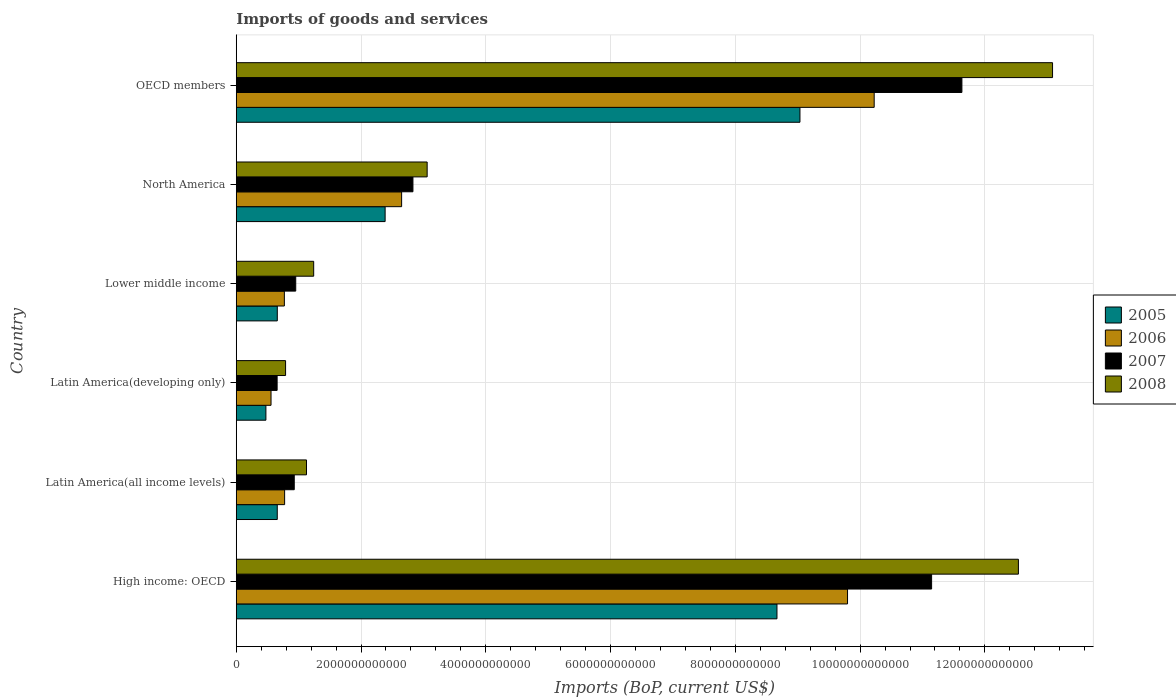How many different coloured bars are there?
Keep it short and to the point. 4. Are the number of bars per tick equal to the number of legend labels?
Offer a very short reply. Yes. Are the number of bars on each tick of the Y-axis equal?
Your answer should be compact. Yes. How many bars are there on the 1st tick from the bottom?
Make the answer very short. 4. What is the label of the 4th group of bars from the top?
Provide a short and direct response. Latin America(developing only). What is the amount spent on imports in 2005 in North America?
Give a very brief answer. 2.39e+12. Across all countries, what is the maximum amount spent on imports in 2006?
Provide a short and direct response. 1.02e+13. Across all countries, what is the minimum amount spent on imports in 2005?
Make the answer very short. 4.75e+11. In which country was the amount spent on imports in 2007 maximum?
Give a very brief answer. OECD members. In which country was the amount spent on imports in 2007 minimum?
Offer a very short reply. Latin America(developing only). What is the total amount spent on imports in 2007 in the graph?
Keep it short and to the point. 2.81e+13. What is the difference between the amount spent on imports in 2005 in Latin America(all income levels) and that in North America?
Make the answer very short. -1.73e+12. What is the difference between the amount spent on imports in 2005 in OECD members and the amount spent on imports in 2007 in Latin America(developing only)?
Keep it short and to the point. 8.38e+12. What is the average amount spent on imports in 2006 per country?
Make the answer very short. 4.13e+12. What is the difference between the amount spent on imports in 2007 and amount spent on imports in 2006 in OECD members?
Your answer should be compact. 1.41e+12. What is the ratio of the amount spent on imports in 2005 in Latin America(developing only) to that in North America?
Offer a very short reply. 0.2. Is the difference between the amount spent on imports in 2007 in Latin America(all income levels) and North America greater than the difference between the amount spent on imports in 2006 in Latin America(all income levels) and North America?
Give a very brief answer. No. What is the difference between the highest and the second highest amount spent on imports in 2005?
Provide a succinct answer. 3.68e+11. What is the difference between the highest and the lowest amount spent on imports in 2007?
Offer a terse response. 1.10e+13. Is the sum of the amount spent on imports in 2005 in Latin America(all income levels) and OECD members greater than the maximum amount spent on imports in 2007 across all countries?
Your answer should be very brief. No. Is it the case that in every country, the sum of the amount spent on imports in 2006 and amount spent on imports in 2005 is greater than the sum of amount spent on imports in 2007 and amount spent on imports in 2008?
Offer a very short reply. No. What does the 4th bar from the bottom in High income: OECD represents?
Your answer should be very brief. 2008. How many bars are there?
Your answer should be compact. 24. How many countries are there in the graph?
Offer a terse response. 6. What is the difference between two consecutive major ticks on the X-axis?
Give a very brief answer. 2.00e+12. Are the values on the major ticks of X-axis written in scientific E-notation?
Offer a very short reply. No. Where does the legend appear in the graph?
Offer a very short reply. Center right. How are the legend labels stacked?
Your response must be concise. Vertical. What is the title of the graph?
Offer a very short reply. Imports of goods and services. What is the label or title of the X-axis?
Offer a very short reply. Imports (BoP, current US$). What is the Imports (BoP, current US$) of 2005 in High income: OECD?
Ensure brevity in your answer.  8.67e+12. What is the Imports (BoP, current US$) in 2006 in High income: OECD?
Provide a short and direct response. 9.80e+12. What is the Imports (BoP, current US$) of 2007 in High income: OECD?
Offer a very short reply. 1.11e+13. What is the Imports (BoP, current US$) in 2008 in High income: OECD?
Offer a very short reply. 1.25e+13. What is the Imports (BoP, current US$) in 2005 in Latin America(all income levels)?
Offer a terse response. 6.57e+11. What is the Imports (BoP, current US$) in 2006 in Latin America(all income levels)?
Make the answer very short. 7.75e+11. What is the Imports (BoP, current US$) in 2007 in Latin America(all income levels)?
Your response must be concise. 9.30e+11. What is the Imports (BoP, current US$) in 2008 in Latin America(all income levels)?
Provide a short and direct response. 1.13e+12. What is the Imports (BoP, current US$) of 2005 in Latin America(developing only)?
Give a very brief answer. 4.75e+11. What is the Imports (BoP, current US$) of 2006 in Latin America(developing only)?
Provide a succinct answer. 5.57e+11. What is the Imports (BoP, current US$) of 2007 in Latin America(developing only)?
Your answer should be very brief. 6.55e+11. What is the Imports (BoP, current US$) of 2008 in Latin America(developing only)?
Provide a succinct answer. 7.91e+11. What is the Imports (BoP, current US$) of 2005 in Lower middle income?
Provide a short and direct response. 6.58e+11. What is the Imports (BoP, current US$) in 2006 in Lower middle income?
Your answer should be very brief. 7.71e+11. What is the Imports (BoP, current US$) in 2007 in Lower middle income?
Keep it short and to the point. 9.53e+11. What is the Imports (BoP, current US$) in 2008 in Lower middle income?
Keep it short and to the point. 1.24e+12. What is the Imports (BoP, current US$) of 2005 in North America?
Ensure brevity in your answer.  2.39e+12. What is the Imports (BoP, current US$) of 2006 in North America?
Keep it short and to the point. 2.65e+12. What is the Imports (BoP, current US$) of 2007 in North America?
Offer a very short reply. 2.83e+12. What is the Imports (BoP, current US$) of 2008 in North America?
Your response must be concise. 3.06e+12. What is the Imports (BoP, current US$) in 2005 in OECD members?
Offer a very short reply. 9.04e+12. What is the Imports (BoP, current US$) of 2006 in OECD members?
Offer a very short reply. 1.02e+13. What is the Imports (BoP, current US$) in 2007 in OECD members?
Make the answer very short. 1.16e+13. What is the Imports (BoP, current US$) of 2008 in OECD members?
Provide a succinct answer. 1.31e+13. Across all countries, what is the maximum Imports (BoP, current US$) in 2005?
Keep it short and to the point. 9.04e+12. Across all countries, what is the maximum Imports (BoP, current US$) in 2006?
Ensure brevity in your answer.  1.02e+13. Across all countries, what is the maximum Imports (BoP, current US$) in 2007?
Provide a succinct answer. 1.16e+13. Across all countries, what is the maximum Imports (BoP, current US$) of 2008?
Make the answer very short. 1.31e+13. Across all countries, what is the minimum Imports (BoP, current US$) in 2005?
Make the answer very short. 4.75e+11. Across all countries, what is the minimum Imports (BoP, current US$) in 2006?
Offer a very short reply. 5.57e+11. Across all countries, what is the minimum Imports (BoP, current US$) in 2007?
Your answer should be very brief. 6.55e+11. Across all countries, what is the minimum Imports (BoP, current US$) of 2008?
Offer a terse response. 7.91e+11. What is the total Imports (BoP, current US$) in 2005 in the graph?
Make the answer very short. 2.19e+13. What is the total Imports (BoP, current US$) of 2006 in the graph?
Give a very brief answer. 2.48e+13. What is the total Imports (BoP, current US$) of 2007 in the graph?
Make the answer very short. 2.81e+13. What is the total Imports (BoP, current US$) of 2008 in the graph?
Ensure brevity in your answer.  3.18e+13. What is the difference between the Imports (BoP, current US$) in 2005 in High income: OECD and that in Latin America(all income levels)?
Offer a very short reply. 8.01e+12. What is the difference between the Imports (BoP, current US$) of 2006 in High income: OECD and that in Latin America(all income levels)?
Your answer should be compact. 9.02e+12. What is the difference between the Imports (BoP, current US$) of 2007 in High income: OECD and that in Latin America(all income levels)?
Your answer should be compact. 1.02e+13. What is the difference between the Imports (BoP, current US$) in 2008 in High income: OECD and that in Latin America(all income levels)?
Offer a very short reply. 1.14e+13. What is the difference between the Imports (BoP, current US$) of 2005 in High income: OECD and that in Latin America(developing only)?
Make the answer very short. 8.19e+12. What is the difference between the Imports (BoP, current US$) of 2006 in High income: OECD and that in Latin America(developing only)?
Offer a terse response. 9.24e+12. What is the difference between the Imports (BoP, current US$) of 2007 in High income: OECD and that in Latin America(developing only)?
Provide a short and direct response. 1.05e+13. What is the difference between the Imports (BoP, current US$) in 2008 in High income: OECD and that in Latin America(developing only)?
Your response must be concise. 1.17e+13. What is the difference between the Imports (BoP, current US$) of 2005 in High income: OECD and that in Lower middle income?
Give a very brief answer. 8.01e+12. What is the difference between the Imports (BoP, current US$) in 2006 in High income: OECD and that in Lower middle income?
Make the answer very short. 9.03e+12. What is the difference between the Imports (BoP, current US$) in 2007 in High income: OECD and that in Lower middle income?
Offer a terse response. 1.02e+13. What is the difference between the Imports (BoP, current US$) of 2008 in High income: OECD and that in Lower middle income?
Provide a short and direct response. 1.13e+13. What is the difference between the Imports (BoP, current US$) of 2005 in High income: OECD and that in North America?
Make the answer very short. 6.28e+12. What is the difference between the Imports (BoP, current US$) of 2006 in High income: OECD and that in North America?
Your response must be concise. 7.15e+12. What is the difference between the Imports (BoP, current US$) in 2007 in High income: OECD and that in North America?
Your answer should be very brief. 8.31e+12. What is the difference between the Imports (BoP, current US$) in 2008 in High income: OECD and that in North America?
Your response must be concise. 9.48e+12. What is the difference between the Imports (BoP, current US$) in 2005 in High income: OECD and that in OECD members?
Offer a very short reply. -3.68e+11. What is the difference between the Imports (BoP, current US$) of 2006 in High income: OECD and that in OECD members?
Your answer should be very brief. -4.27e+11. What is the difference between the Imports (BoP, current US$) of 2007 in High income: OECD and that in OECD members?
Your answer should be compact. -4.86e+11. What is the difference between the Imports (BoP, current US$) in 2008 in High income: OECD and that in OECD members?
Provide a short and direct response. -5.47e+11. What is the difference between the Imports (BoP, current US$) in 2005 in Latin America(all income levels) and that in Latin America(developing only)?
Your response must be concise. 1.82e+11. What is the difference between the Imports (BoP, current US$) in 2006 in Latin America(all income levels) and that in Latin America(developing only)?
Keep it short and to the point. 2.18e+11. What is the difference between the Imports (BoP, current US$) in 2007 in Latin America(all income levels) and that in Latin America(developing only)?
Keep it short and to the point. 2.75e+11. What is the difference between the Imports (BoP, current US$) in 2008 in Latin America(all income levels) and that in Latin America(developing only)?
Your answer should be compact. 3.35e+11. What is the difference between the Imports (BoP, current US$) of 2005 in Latin America(all income levels) and that in Lower middle income?
Give a very brief answer. -6.55e+08. What is the difference between the Imports (BoP, current US$) of 2006 in Latin America(all income levels) and that in Lower middle income?
Keep it short and to the point. 4.18e+09. What is the difference between the Imports (BoP, current US$) in 2007 in Latin America(all income levels) and that in Lower middle income?
Offer a very short reply. -2.36e+1. What is the difference between the Imports (BoP, current US$) in 2008 in Latin America(all income levels) and that in Lower middle income?
Keep it short and to the point. -1.15e+11. What is the difference between the Imports (BoP, current US$) of 2005 in Latin America(all income levels) and that in North America?
Offer a terse response. -1.73e+12. What is the difference between the Imports (BoP, current US$) in 2006 in Latin America(all income levels) and that in North America?
Make the answer very short. -1.88e+12. What is the difference between the Imports (BoP, current US$) in 2007 in Latin America(all income levels) and that in North America?
Ensure brevity in your answer.  -1.90e+12. What is the difference between the Imports (BoP, current US$) of 2008 in Latin America(all income levels) and that in North America?
Your answer should be compact. -1.93e+12. What is the difference between the Imports (BoP, current US$) of 2005 in Latin America(all income levels) and that in OECD members?
Offer a terse response. -8.38e+12. What is the difference between the Imports (BoP, current US$) in 2006 in Latin America(all income levels) and that in OECD members?
Make the answer very short. -9.45e+12. What is the difference between the Imports (BoP, current US$) in 2007 in Latin America(all income levels) and that in OECD members?
Offer a terse response. -1.07e+13. What is the difference between the Imports (BoP, current US$) of 2008 in Latin America(all income levels) and that in OECD members?
Your answer should be compact. -1.20e+13. What is the difference between the Imports (BoP, current US$) in 2005 in Latin America(developing only) and that in Lower middle income?
Provide a succinct answer. -1.83e+11. What is the difference between the Imports (BoP, current US$) in 2006 in Latin America(developing only) and that in Lower middle income?
Provide a succinct answer. -2.14e+11. What is the difference between the Imports (BoP, current US$) of 2007 in Latin America(developing only) and that in Lower middle income?
Keep it short and to the point. -2.98e+11. What is the difference between the Imports (BoP, current US$) of 2008 in Latin America(developing only) and that in Lower middle income?
Make the answer very short. -4.51e+11. What is the difference between the Imports (BoP, current US$) of 2005 in Latin America(developing only) and that in North America?
Ensure brevity in your answer.  -1.91e+12. What is the difference between the Imports (BoP, current US$) in 2006 in Latin America(developing only) and that in North America?
Keep it short and to the point. -2.09e+12. What is the difference between the Imports (BoP, current US$) of 2007 in Latin America(developing only) and that in North America?
Provide a succinct answer. -2.18e+12. What is the difference between the Imports (BoP, current US$) in 2008 in Latin America(developing only) and that in North America?
Provide a succinct answer. -2.27e+12. What is the difference between the Imports (BoP, current US$) of 2005 in Latin America(developing only) and that in OECD members?
Your answer should be compact. -8.56e+12. What is the difference between the Imports (BoP, current US$) of 2006 in Latin America(developing only) and that in OECD members?
Offer a terse response. -9.67e+12. What is the difference between the Imports (BoP, current US$) in 2007 in Latin America(developing only) and that in OECD members?
Ensure brevity in your answer.  -1.10e+13. What is the difference between the Imports (BoP, current US$) in 2008 in Latin America(developing only) and that in OECD members?
Offer a terse response. -1.23e+13. What is the difference between the Imports (BoP, current US$) in 2005 in Lower middle income and that in North America?
Your answer should be very brief. -1.73e+12. What is the difference between the Imports (BoP, current US$) in 2006 in Lower middle income and that in North America?
Ensure brevity in your answer.  -1.88e+12. What is the difference between the Imports (BoP, current US$) of 2007 in Lower middle income and that in North America?
Offer a very short reply. -1.88e+12. What is the difference between the Imports (BoP, current US$) in 2008 in Lower middle income and that in North America?
Ensure brevity in your answer.  -1.82e+12. What is the difference between the Imports (BoP, current US$) in 2005 in Lower middle income and that in OECD members?
Your response must be concise. -8.38e+12. What is the difference between the Imports (BoP, current US$) in 2006 in Lower middle income and that in OECD members?
Offer a very short reply. -9.45e+12. What is the difference between the Imports (BoP, current US$) in 2007 in Lower middle income and that in OECD members?
Keep it short and to the point. -1.07e+13. What is the difference between the Imports (BoP, current US$) in 2008 in Lower middle income and that in OECD members?
Keep it short and to the point. -1.18e+13. What is the difference between the Imports (BoP, current US$) of 2005 in North America and that in OECD members?
Make the answer very short. -6.65e+12. What is the difference between the Imports (BoP, current US$) of 2006 in North America and that in OECD members?
Offer a very short reply. -7.57e+12. What is the difference between the Imports (BoP, current US$) of 2007 in North America and that in OECD members?
Your response must be concise. -8.80e+12. What is the difference between the Imports (BoP, current US$) of 2008 in North America and that in OECD members?
Make the answer very short. -1.00e+13. What is the difference between the Imports (BoP, current US$) of 2005 in High income: OECD and the Imports (BoP, current US$) of 2006 in Latin America(all income levels)?
Give a very brief answer. 7.89e+12. What is the difference between the Imports (BoP, current US$) in 2005 in High income: OECD and the Imports (BoP, current US$) in 2007 in Latin America(all income levels)?
Your answer should be compact. 7.74e+12. What is the difference between the Imports (BoP, current US$) in 2005 in High income: OECD and the Imports (BoP, current US$) in 2008 in Latin America(all income levels)?
Provide a short and direct response. 7.54e+12. What is the difference between the Imports (BoP, current US$) of 2006 in High income: OECD and the Imports (BoP, current US$) of 2007 in Latin America(all income levels)?
Give a very brief answer. 8.87e+12. What is the difference between the Imports (BoP, current US$) of 2006 in High income: OECD and the Imports (BoP, current US$) of 2008 in Latin America(all income levels)?
Offer a terse response. 8.67e+12. What is the difference between the Imports (BoP, current US$) of 2007 in High income: OECD and the Imports (BoP, current US$) of 2008 in Latin America(all income levels)?
Give a very brief answer. 1.00e+13. What is the difference between the Imports (BoP, current US$) in 2005 in High income: OECD and the Imports (BoP, current US$) in 2006 in Latin America(developing only)?
Offer a very short reply. 8.11e+12. What is the difference between the Imports (BoP, current US$) of 2005 in High income: OECD and the Imports (BoP, current US$) of 2007 in Latin America(developing only)?
Make the answer very short. 8.01e+12. What is the difference between the Imports (BoP, current US$) of 2005 in High income: OECD and the Imports (BoP, current US$) of 2008 in Latin America(developing only)?
Your answer should be very brief. 7.88e+12. What is the difference between the Imports (BoP, current US$) in 2006 in High income: OECD and the Imports (BoP, current US$) in 2007 in Latin America(developing only)?
Your answer should be compact. 9.14e+12. What is the difference between the Imports (BoP, current US$) in 2006 in High income: OECD and the Imports (BoP, current US$) in 2008 in Latin America(developing only)?
Provide a succinct answer. 9.01e+12. What is the difference between the Imports (BoP, current US$) in 2007 in High income: OECD and the Imports (BoP, current US$) in 2008 in Latin America(developing only)?
Ensure brevity in your answer.  1.04e+13. What is the difference between the Imports (BoP, current US$) in 2005 in High income: OECD and the Imports (BoP, current US$) in 2006 in Lower middle income?
Your answer should be compact. 7.90e+12. What is the difference between the Imports (BoP, current US$) in 2005 in High income: OECD and the Imports (BoP, current US$) in 2007 in Lower middle income?
Make the answer very short. 7.71e+12. What is the difference between the Imports (BoP, current US$) of 2005 in High income: OECD and the Imports (BoP, current US$) of 2008 in Lower middle income?
Your answer should be compact. 7.43e+12. What is the difference between the Imports (BoP, current US$) in 2006 in High income: OECD and the Imports (BoP, current US$) in 2007 in Lower middle income?
Provide a short and direct response. 8.85e+12. What is the difference between the Imports (BoP, current US$) in 2006 in High income: OECD and the Imports (BoP, current US$) in 2008 in Lower middle income?
Ensure brevity in your answer.  8.56e+12. What is the difference between the Imports (BoP, current US$) in 2007 in High income: OECD and the Imports (BoP, current US$) in 2008 in Lower middle income?
Your answer should be compact. 9.91e+12. What is the difference between the Imports (BoP, current US$) in 2005 in High income: OECD and the Imports (BoP, current US$) in 2006 in North America?
Make the answer very short. 6.02e+12. What is the difference between the Imports (BoP, current US$) of 2005 in High income: OECD and the Imports (BoP, current US$) of 2007 in North America?
Your answer should be compact. 5.84e+12. What is the difference between the Imports (BoP, current US$) of 2005 in High income: OECD and the Imports (BoP, current US$) of 2008 in North America?
Keep it short and to the point. 5.61e+12. What is the difference between the Imports (BoP, current US$) in 2006 in High income: OECD and the Imports (BoP, current US$) in 2007 in North America?
Provide a short and direct response. 6.97e+12. What is the difference between the Imports (BoP, current US$) in 2006 in High income: OECD and the Imports (BoP, current US$) in 2008 in North America?
Provide a short and direct response. 6.74e+12. What is the difference between the Imports (BoP, current US$) of 2007 in High income: OECD and the Imports (BoP, current US$) of 2008 in North America?
Offer a terse response. 8.09e+12. What is the difference between the Imports (BoP, current US$) of 2005 in High income: OECD and the Imports (BoP, current US$) of 2006 in OECD members?
Offer a very short reply. -1.56e+12. What is the difference between the Imports (BoP, current US$) of 2005 in High income: OECD and the Imports (BoP, current US$) of 2007 in OECD members?
Provide a short and direct response. -2.96e+12. What is the difference between the Imports (BoP, current US$) in 2005 in High income: OECD and the Imports (BoP, current US$) in 2008 in OECD members?
Your answer should be compact. -4.42e+12. What is the difference between the Imports (BoP, current US$) of 2006 in High income: OECD and the Imports (BoP, current US$) of 2007 in OECD members?
Provide a succinct answer. -1.83e+12. What is the difference between the Imports (BoP, current US$) of 2006 in High income: OECD and the Imports (BoP, current US$) of 2008 in OECD members?
Offer a terse response. -3.29e+12. What is the difference between the Imports (BoP, current US$) in 2007 in High income: OECD and the Imports (BoP, current US$) in 2008 in OECD members?
Offer a very short reply. -1.94e+12. What is the difference between the Imports (BoP, current US$) of 2005 in Latin America(all income levels) and the Imports (BoP, current US$) of 2006 in Latin America(developing only)?
Your response must be concise. 9.99e+1. What is the difference between the Imports (BoP, current US$) of 2005 in Latin America(all income levels) and the Imports (BoP, current US$) of 2007 in Latin America(developing only)?
Ensure brevity in your answer.  2.04e+09. What is the difference between the Imports (BoP, current US$) of 2005 in Latin America(all income levels) and the Imports (BoP, current US$) of 2008 in Latin America(developing only)?
Provide a succinct answer. -1.33e+11. What is the difference between the Imports (BoP, current US$) in 2006 in Latin America(all income levels) and the Imports (BoP, current US$) in 2007 in Latin America(developing only)?
Give a very brief answer. 1.20e+11. What is the difference between the Imports (BoP, current US$) of 2006 in Latin America(all income levels) and the Imports (BoP, current US$) of 2008 in Latin America(developing only)?
Make the answer very short. -1.55e+1. What is the difference between the Imports (BoP, current US$) in 2007 in Latin America(all income levels) and the Imports (BoP, current US$) in 2008 in Latin America(developing only)?
Offer a terse response. 1.39e+11. What is the difference between the Imports (BoP, current US$) in 2005 in Latin America(all income levels) and the Imports (BoP, current US$) in 2006 in Lower middle income?
Ensure brevity in your answer.  -1.14e+11. What is the difference between the Imports (BoP, current US$) in 2005 in Latin America(all income levels) and the Imports (BoP, current US$) in 2007 in Lower middle income?
Your response must be concise. -2.96e+11. What is the difference between the Imports (BoP, current US$) in 2005 in Latin America(all income levels) and the Imports (BoP, current US$) in 2008 in Lower middle income?
Give a very brief answer. -5.84e+11. What is the difference between the Imports (BoP, current US$) in 2006 in Latin America(all income levels) and the Imports (BoP, current US$) in 2007 in Lower middle income?
Your answer should be compact. -1.78e+11. What is the difference between the Imports (BoP, current US$) of 2006 in Latin America(all income levels) and the Imports (BoP, current US$) of 2008 in Lower middle income?
Your answer should be compact. -4.66e+11. What is the difference between the Imports (BoP, current US$) in 2007 in Latin America(all income levels) and the Imports (BoP, current US$) in 2008 in Lower middle income?
Your answer should be very brief. -3.12e+11. What is the difference between the Imports (BoP, current US$) in 2005 in Latin America(all income levels) and the Imports (BoP, current US$) in 2006 in North America?
Provide a succinct answer. -1.99e+12. What is the difference between the Imports (BoP, current US$) of 2005 in Latin America(all income levels) and the Imports (BoP, current US$) of 2007 in North America?
Provide a succinct answer. -2.17e+12. What is the difference between the Imports (BoP, current US$) in 2005 in Latin America(all income levels) and the Imports (BoP, current US$) in 2008 in North America?
Your response must be concise. -2.40e+12. What is the difference between the Imports (BoP, current US$) in 2006 in Latin America(all income levels) and the Imports (BoP, current US$) in 2007 in North America?
Offer a terse response. -2.06e+12. What is the difference between the Imports (BoP, current US$) in 2006 in Latin America(all income levels) and the Imports (BoP, current US$) in 2008 in North America?
Make the answer very short. -2.28e+12. What is the difference between the Imports (BoP, current US$) of 2007 in Latin America(all income levels) and the Imports (BoP, current US$) of 2008 in North America?
Make the answer very short. -2.13e+12. What is the difference between the Imports (BoP, current US$) of 2005 in Latin America(all income levels) and the Imports (BoP, current US$) of 2006 in OECD members?
Give a very brief answer. -9.57e+12. What is the difference between the Imports (BoP, current US$) in 2005 in Latin America(all income levels) and the Imports (BoP, current US$) in 2007 in OECD members?
Provide a succinct answer. -1.10e+13. What is the difference between the Imports (BoP, current US$) of 2005 in Latin America(all income levels) and the Imports (BoP, current US$) of 2008 in OECD members?
Ensure brevity in your answer.  -1.24e+13. What is the difference between the Imports (BoP, current US$) in 2006 in Latin America(all income levels) and the Imports (BoP, current US$) in 2007 in OECD members?
Make the answer very short. -1.09e+13. What is the difference between the Imports (BoP, current US$) in 2006 in Latin America(all income levels) and the Imports (BoP, current US$) in 2008 in OECD members?
Make the answer very short. -1.23e+13. What is the difference between the Imports (BoP, current US$) of 2007 in Latin America(all income levels) and the Imports (BoP, current US$) of 2008 in OECD members?
Offer a very short reply. -1.22e+13. What is the difference between the Imports (BoP, current US$) in 2005 in Latin America(developing only) and the Imports (BoP, current US$) in 2006 in Lower middle income?
Your response must be concise. -2.96e+11. What is the difference between the Imports (BoP, current US$) in 2005 in Latin America(developing only) and the Imports (BoP, current US$) in 2007 in Lower middle income?
Provide a short and direct response. -4.78e+11. What is the difference between the Imports (BoP, current US$) in 2005 in Latin America(developing only) and the Imports (BoP, current US$) in 2008 in Lower middle income?
Your answer should be compact. -7.66e+11. What is the difference between the Imports (BoP, current US$) in 2006 in Latin America(developing only) and the Imports (BoP, current US$) in 2007 in Lower middle income?
Offer a very short reply. -3.96e+11. What is the difference between the Imports (BoP, current US$) in 2006 in Latin America(developing only) and the Imports (BoP, current US$) in 2008 in Lower middle income?
Keep it short and to the point. -6.84e+11. What is the difference between the Imports (BoP, current US$) of 2007 in Latin America(developing only) and the Imports (BoP, current US$) of 2008 in Lower middle income?
Offer a terse response. -5.86e+11. What is the difference between the Imports (BoP, current US$) in 2005 in Latin America(developing only) and the Imports (BoP, current US$) in 2006 in North America?
Offer a terse response. -2.18e+12. What is the difference between the Imports (BoP, current US$) of 2005 in Latin America(developing only) and the Imports (BoP, current US$) of 2007 in North America?
Offer a very short reply. -2.36e+12. What is the difference between the Imports (BoP, current US$) in 2005 in Latin America(developing only) and the Imports (BoP, current US$) in 2008 in North America?
Make the answer very short. -2.58e+12. What is the difference between the Imports (BoP, current US$) of 2006 in Latin America(developing only) and the Imports (BoP, current US$) of 2007 in North America?
Make the answer very short. -2.27e+12. What is the difference between the Imports (BoP, current US$) in 2006 in Latin America(developing only) and the Imports (BoP, current US$) in 2008 in North America?
Ensure brevity in your answer.  -2.50e+12. What is the difference between the Imports (BoP, current US$) in 2007 in Latin America(developing only) and the Imports (BoP, current US$) in 2008 in North America?
Your response must be concise. -2.40e+12. What is the difference between the Imports (BoP, current US$) of 2005 in Latin America(developing only) and the Imports (BoP, current US$) of 2006 in OECD members?
Make the answer very short. -9.75e+12. What is the difference between the Imports (BoP, current US$) of 2005 in Latin America(developing only) and the Imports (BoP, current US$) of 2007 in OECD members?
Your answer should be compact. -1.12e+13. What is the difference between the Imports (BoP, current US$) in 2005 in Latin America(developing only) and the Imports (BoP, current US$) in 2008 in OECD members?
Offer a very short reply. -1.26e+13. What is the difference between the Imports (BoP, current US$) of 2006 in Latin America(developing only) and the Imports (BoP, current US$) of 2007 in OECD members?
Provide a succinct answer. -1.11e+13. What is the difference between the Imports (BoP, current US$) of 2006 in Latin America(developing only) and the Imports (BoP, current US$) of 2008 in OECD members?
Ensure brevity in your answer.  -1.25e+13. What is the difference between the Imports (BoP, current US$) of 2007 in Latin America(developing only) and the Imports (BoP, current US$) of 2008 in OECD members?
Your answer should be very brief. -1.24e+13. What is the difference between the Imports (BoP, current US$) in 2005 in Lower middle income and the Imports (BoP, current US$) in 2006 in North America?
Offer a very short reply. -1.99e+12. What is the difference between the Imports (BoP, current US$) of 2005 in Lower middle income and the Imports (BoP, current US$) of 2007 in North America?
Make the answer very short. -2.17e+12. What is the difference between the Imports (BoP, current US$) in 2005 in Lower middle income and the Imports (BoP, current US$) in 2008 in North America?
Offer a terse response. -2.40e+12. What is the difference between the Imports (BoP, current US$) in 2006 in Lower middle income and the Imports (BoP, current US$) in 2007 in North America?
Ensure brevity in your answer.  -2.06e+12. What is the difference between the Imports (BoP, current US$) in 2006 in Lower middle income and the Imports (BoP, current US$) in 2008 in North America?
Give a very brief answer. -2.29e+12. What is the difference between the Imports (BoP, current US$) of 2007 in Lower middle income and the Imports (BoP, current US$) of 2008 in North America?
Your answer should be compact. -2.11e+12. What is the difference between the Imports (BoP, current US$) of 2005 in Lower middle income and the Imports (BoP, current US$) of 2006 in OECD members?
Provide a short and direct response. -9.57e+12. What is the difference between the Imports (BoP, current US$) in 2005 in Lower middle income and the Imports (BoP, current US$) in 2007 in OECD members?
Your answer should be compact. -1.10e+13. What is the difference between the Imports (BoP, current US$) of 2005 in Lower middle income and the Imports (BoP, current US$) of 2008 in OECD members?
Ensure brevity in your answer.  -1.24e+13. What is the difference between the Imports (BoP, current US$) in 2006 in Lower middle income and the Imports (BoP, current US$) in 2007 in OECD members?
Provide a short and direct response. -1.09e+13. What is the difference between the Imports (BoP, current US$) of 2006 in Lower middle income and the Imports (BoP, current US$) of 2008 in OECD members?
Your answer should be very brief. -1.23e+13. What is the difference between the Imports (BoP, current US$) of 2007 in Lower middle income and the Imports (BoP, current US$) of 2008 in OECD members?
Your response must be concise. -1.21e+13. What is the difference between the Imports (BoP, current US$) of 2005 in North America and the Imports (BoP, current US$) of 2006 in OECD members?
Your answer should be very brief. -7.84e+12. What is the difference between the Imports (BoP, current US$) of 2005 in North America and the Imports (BoP, current US$) of 2007 in OECD members?
Your answer should be compact. -9.25e+12. What is the difference between the Imports (BoP, current US$) of 2005 in North America and the Imports (BoP, current US$) of 2008 in OECD members?
Your answer should be compact. -1.07e+13. What is the difference between the Imports (BoP, current US$) in 2006 in North America and the Imports (BoP, current US$) in 2007 in OECD members?
Your response must be concise. -8.98e+12. What is the difference between the Imports (BoP, current US$) of 2006 in North America and the Imports (BoP, current US$) of 2008 in OECD members?
Offer a terse response. -1.04e+13. What is the difference between the Imports (BoP, current US$) in 2007 in North America and the Imports (BoP, current US$) in 2008 in OECD members?
Your answer should be very brief. -1.03e+13. What is the average Imports (BoP, current US$) in 2005 per country?
Your answer should be compact. 3.65e+12. What is the average Imports (BoP, current US$) in 2006 per country?
Give a very brief answer. 4.13e+12. What is the average Imports (BoP, current US$) in 2007 per country?
Provide a short and direct response. 4.69e+12. What is the average Imports (BoP, current US$) of 2008 per country?
Provide a succinct answer. 5.31e+12. What is the difference between the Imports (BoP, current US$) of 2005 and Imports (BoP, current US$) of 2006 in High income: OECD?
Your response must be concise. -1.13e+12. What is the difference between the Imports (BoP, current US$) of 2005 and Imports (BoP, current US$) of 2007 in High income: OECD?
Provide a short and direct response. -2.48e+12. What is the difference between the Imports (BoP, current US$) of 2005 and Imports (BoP, current US$) of 2008 in High income: OECD?
Provide a short and direct response. -3.87e+12. What is the difference between the Imports (BoP, current US$) of 2006 and Imports (BoP, current US$) of 2007 in High income: OECD?
Keep it short and to the point. -1.35e+12. What is the difference between the Imports (BoP, current US$) of 2006 and Imports (BoP, current US$) of 2008 in High income: OECD?
Offer a very short reply. -2.74e+12. What is the difference between the Imports (BoP, current US$) in 2007 and Imports (BoP, current US$) in 2008 in High income: OECD?
Ensure brevity in your answer.  -1.39e+12. What is the difference between the Imports (BoP, current US$) in 2005 and Imports (BoP, current US$) in 2006 in Latin America(all income levels)?
Ensure brevity in your answer.  -1.18e+11. What is the difference between the Imports (BoP, current US$) of 2005 and Imports (BoP, current US$) of 2007 in Latin America(all income levels)?
Provide a short and direct response. -2.72e+11. What is the difference between the Imports (BoP, current US$) in 2005 and Imports (BoP, current US$) in 2008 in Latin America(all income levels)?
Ensure brevity in your answer.  -4.69e+11. What is the difference between the Imports (BoP, current US$) of 2006 and Imports (BoP, current US$) of 2007 in Latin America(all income levels)?
Provide a succinct answer. -1.54e+11. What is the difference between the Imports (BoP, current US$) of 2006 and Imports (BoP, current US$) of 2008 in Latin America(all income levels)?
Your answer should be very brief. -3.51e+11. What is the difference between the Imports (BoP, current US$) in 2007 and Imports (BoP, current US$) in 2008 in Latin America(all income levels)?
Provide a short and direct response. -1.96e+11. What is the difference between the Imports (BoP, current US$) of 2005 and Imports (BoP, current US$) of 2006 in Latin America(developing only)?
Provide a short and direct response. -8.20e+1. What is the difference between the Imports (BoP, current US$) of 2005 and Imports (BoP, current US$) of 2007 in Latin America(developing only)?
Your answer should be compact. -1.80e+11. What is the difference between the Imports (BoP, current US$) in 2005 and Imports (BoP, current US$) in 2008 in Latin America(developing only)?
Your answer should be very brief. -3.15e+11. What is the difference between the Imports (BoP, current US$) in 2006 and Imports (BoP, current US$) in 2007 in Latin America(developing only)?
Offer a very short reply. -9.79e+1. What is the difference between the Imports (BoP, current US$) in 2006 and Imports (BoP, current US$) in 2008 in Latin America(developing only)?
Offer a terse response. -2.33e+11. What is the difference between the Imports (BoP, current US$) of 2007 and Imports (BoP, current US$) of 2008 in Latin America(developing only)?
Keep it short and to the point. -1.36e+11. What is the difference between the Imports (BoP, current US$) in 2005 and Imports (BoP, current US$) in 2006 in Lower middle income?
Offer a terse response. -1.13e+11. What is the difference between the Imports (BoP, current US$) of 2005 and Imports (BoP, current US$) of 2007 in Lower middle income?
Make the answer very short. -2.95e+11. What is the difference between the Imports (BoP, current US$) in 2005 and Imports (BoP, current US$) in 2008 in Lower middle income?
Make the answer very short. -5.83e+11. What is the difference between the Imports (BoP, current US$) in 2006 and Imports (BoP, current US$) in 2007 in Lower middle income?
Provide a short and direct response. -1.82e+11. What is the difference between the Imports (BoP, current US$) in 2006 and Imports (BoP, current US$) in 2008 in Lower middle income?
Provide a succinct answer. -4.70e+11. What is the difference between the Imports (BoP, current US$) of 2007 and Imports (BoP, current US$) of 2008 in Lower middle income?
Offer a terse response. -2.88e+11. What is the difference between the Imports (BoP, current US$) of 2005 and Imports (BoP, current US$) of 2006 in North America?
Your response must be concise. -2.65e+11. What is the difference between the Imports (BoP, current US$) of 2005 and Imports (BoP, current US$) of 2007 in North America?
Your response must be concise. -4.46e+11. What is the difference between the Imports (BoP, current US$) in 2005 and Imports (BoP, current US$) in 2008 in North America?
Provide a short and direct response. -6.74e+11. What is the difference between the Imports (BoP, current US$) of 2006 and Imports (BoP, current US$) of 2007 in North America?
Offer a terse response. -1.81e+11. What is the difference between the Imports (BoP, current US$) of 2006 and Imports (BoP, current US$) of 2008 in North America?
Offer a terse response. -4.09e+11. What is the difference between the Imports (BoP, current US$) of 2007 and Imports (BoP, current US$) of 2008 in North America?
Make the answer very short. -2.28e+11. What is the difference between the Imports (BoP, current US$) of 2005 and Imports (BoP, current US$) of 2006 in OECD members?
Provide a succinct answer. -1.19e+12. What is the difference between the Imports (BoP, current US$) in 2005 and Imports (BoP, current US$) in 2007 in OECD members?
Keep it short and to the point. -2.60e+12. What is the difference between the Imports (BoP, current US$) in 2005 and Imports (BoP, current US$) in 2008 in OECD members?
Provide a short and direct response. -4.05e+12. What is the difference between the Imports (BoP, current US$) of 2006 and Imports (BoP, current US$) of 2007 in OECD members?
Your answer should be very brief. -1.41e+12. What is the difference between the Imports (BoP, current US$) in 2006 and Imports (BoP, current US$) in 2008 in OECD members?
Provide a succinct answer. -2.86e+12. What is the difference between the Imports (BoP, current US$) in 2007 and Imports (BoP, current US$) in 2008 in OECD members?
Ensure brevity in your answer.  -1.45e+12. What is the ratio of the Imports (BoP, current US$) in 2005 in High income: OECD to that in Latin America(all income levels)?
Your answer should be compact. 13.19. What is the ratio of the Imports (BoP, current US$) in 2006 in High income: OECD to that in Latin America(all income levels)?
Offer a terse response. 12.64. What is the ratio of the Imports (BoP, current US$) of 2007 in High income: OECD to that in Latin America(all income levels)?
Offer a terse response. 11.99. What is the ratio of the Imports (BoP, current US$) of 2008 in High income: OECD to that in Latin America(all income levels)?
Keep it short and to the point. 11.13. What is the ratio of the Imports (BoP, current US$) of 2005 in High income: OECD to that in Latin America(developing only)?
Make the answer very short. 18.23. What is the ratio of the Imports (BoP, current US$) of 2006 in High income: OECD to that in Latin America(developing only)?
Provide a short and direct response. 17.58. What is the ratio of the Imports (BoP, current US$) of 2007 in High income: OECD to that in Latin America(developing only)?
Provide a succinct answer. 17.01. What is the ratio of the Imports (BoP, current US$) of 2008 in High income: OECD to that in Latin America(developing only)?
Your answer should be very brief. 15.86. What is the ratio of the Imports (BoP, current US$) in 2005 in High income: OECD to that in Lower middle income?
Your answer should be compact. 13.17. What is the ratio of the Imports (BoP, current US$) in 2006 in High income: OECD to that in Lower middle income?
Your answer should be very brief. 12.71. What is the ratio of the Imports (BoP, current US$) in 2007 in High income: OECD to that in Lower middle income?
Provide a succinct answer. 11.69. What is the ratio of the Imports (BoP, current US$) in 2005 in High income: OECD to that in North America?
Make the answer very short. 3.63. What is the ratio of the Imports (BoP, current US$) of 2006 in High income: OECD to that in North America?
Your response must be concise. 3.7. What is the ratio of the Imports (BoP, current US$) of 2007 in High income: OECD to that in North America?
Your response must be concise. 3.94. What is the ratio of the Imports (BoP, current US$) of 2008 in High income: OECD to that in North America?
Ensure brevity in your answer.  4.1. What is the ratio of the Imports (BoP, current US$) in 2005 in High income: OECD to that in OECD members?
Make the answer very short. 0.96. What is the ratio of the Imports (BoP, current US$) of 2006 in High income: OECD to that in OECD members?
Give a very brief answer. 0.96. What is the ratio of the Imports (BoP, current US$) of 2007 in High income: OECD to that in OECD members?
Make the answer very short. 0.96. What is the ratio of the Imports (BoP, current US$) in 2008 in High income: OECD to that in OECD members?
Your answer should be very brief. 0.96. What is the ratio of the Imports (BoP, current US$) of 2005 in Latin America(all income levels) to that in Latin America(developing only)?
Give a very brief answer. 1.38. What is the ratio of the Imports (BoP, current US$) of 2006 in Latin America(all income levels) to that in Latin America(developing only)?
Your answer should be compact. 1.39. What is the ratio of the Imports (BoP, current US$) of 2007 in Latin America(all income levels) to that in Latin America(developing only)?
Keep it short and to the point. 1.42. What is the ratio of the Imports (BoP, current US$) in 2008 in Latin America(all income levels) to that in Latin America(developing only)?
Offer a very short reply. 1.42. What is the ratio of the Imports (BoP, current US$) of 2005 in Latin America(all income levels) to that in Lower middle income?
Your response must be concise. 1. What is the ratio of the Imports (BoP, current US$) in 2006 in Latin America(all income levels) to that in Lower middle income?
Your answer should be very brief. 1.01. What is the ratio of the Imports (BoP, current US$) in 2007 in Latin America(all income levels) to that in Lower middle income?
Ensure brevity in your answer.  0.98. What is the ratio of the Imports (BoP, current US$) in 2008 in Latin America(all income levels) to that in Lower middle income?
Your answer should be compact. 0.91. What is the ratio of the Imports (BoP, current US$) in 2005 in Latin America(all income levels) to that in North America?
Your response must be concise. 0.28. What is the ratio of the Imports (BoP, current US$) of 2006 in Latin America(all income levels) to that in North America?
Your answer should be compact. 0.29. What is the ratio of the Imports (BoP, current US$) in 2007 in Latin America(all income levels) to that in North America?
Your answer should be compact. 0.33. What is the ratio of the Imports (BoP, current US$) in 2008 in Latin America(all income levels) to that in North America?
Give a very brief answer. 0.37. What is the ratio of the Imports (BoP, current US$) in 2005 in Latin America(all income levels) to that in OECD members?
Your answer should be very brief. 0.07. What is the ratio of the Imports (BoP, current US$) of 2006 in Latin America(all income levels) to that in OECD members?
Offer a terse response. 0.08. What is the ratio of the Imports (BoP, current US$) in 2007 in Latin America(all income levels) to that in OECD members?
Provide a succinct answer. 0.08. What is the ratio of the Imports (BoP, current US$) in 2008 in Latin America(all income levels) to that in OECD members?
Provide a succinct answer. 0.09. What is the ratio of the Imports (BoP, current US$) of 2005 in Latin America(developing only) to that in Lower middle income?
Your answer should be very brief. 0.72. What is the ratio of the Imports (BoP, current US$) in 2006 in Latin America(developing only) to that in Lower middle income?
Make the answer very short. 0.72. What is the ratio of the Imports (BoP, current US$) of 2007 in Latin America(developing only) to that in Lower middle income?
Give a very brief answer. 0.69. What is the ratio of the Imports (BoP, current US$) in 2008 in Latin America(developing only) to that in Lower middle income?
Make the answer very short. 0.64. What is the ratio of the Imports (BoP, current US$) in 2005 in Latin America(developing only) to that in North America?
Your answer should be very brief. 0.2. What is the ratio of the Imports (BoP, current US$) of 2006 in Latin America(developing only) to that in North America?
Keep it short and to the point. 0.21. What is the ratio of the Imports (BoP, current US$) of 2007 in Latin America(developing only) to that in North America?
Provide a succinct answer. 0.23. What is the ratio of the Imports (BoP, current US$) in 2008 in Latin America(developing only) to that in North America?
Keep it short and to the point. 0.26. What is the ratio of the Imports (BoP, current US$) in 2005 in Latin America(developing only) to that in OECD members?
Ensure brevity in your answer.  0.05. What is the ratio of the Imports (BoP, current US$) of 2006 in Latin America(developing only) to that in OECD members?
Keep it short and to the point. 0.05. What is the ratio of the Imports (BoP, current US$) in 2007 in Latin America(developing only) to that in OECD members?
Provide a short and direct response. 0.06. What is the ratio of the Imports (BoP, current US$) of 2008 in Latin America(developing only) to that in OECD members?
Provide a short and direct response. 0.06. What is the ratio of the Imports (BoP, current US$) in 2005 in Lower middle income to that in North America?
Your response must be concise. 0.28. What is the ratio of the Imports (BoP, current US$) of 2006 in Lower middle income to that in North America?
Provide a short and direct response. 0.29. What is the ratio of the Imports (BoP, current US$) in 2007 in Lower middle income to that in North America?
Make the answer very short. 0.34. What is the ratio of the Imports (BoP, current US$) in 2008 in Lower middle income to that in North America?
Offer a very short reply. 0.41. What is the ratio of the Imports (BoP, current US$) in 2005 in Lower middle income to that in OECD members?
Your answer should be very brief. 0.07. What is the ratio of the Imports (BoP, current US$) of 2006 in Lower middle income to that in OECD members?
Your answer should be very brief. 0.08. What is the ratio of the Imports (BoP, current US$) of 2007 in Lower middle income to that in OECD members?
Make the answer very short. 0.08. What is the ratio of the Imports (BoP, current US$) of 2008 in Lower middle income to that in OECD members?
Your answer should be very brief. 0.09. What is the ratio of the Imports (BoP, current US$) of 2005 in North America to that in OECD members?
Provide a short and direct response. 0.26. What is the ratio of the Imports (BoP, current US$) of 2006 in North America to that in OECD members?
Keep it short and to the point. 0.26. What is the ratio of the Imports (BoP, current US$) in 2007 in North America to that in OECD members?
Keep it short and to the point. 0.24. What is the ratio of the Imports (BoP, current US$) in 2008 in North America to that in OECD members?
Make the answer very short. 0.23. What is the difference between the highest and the second highest Imports (BoP, current US$) of 2005?
Make the answer very short. 3.68e+11. What is the difference between the highest and the second highest Imports (BoP, current US$) of 2006?
Keep it short and to the point. 4.27e+11. What is the difference between the highest and the second highest Imports (BoP, current US$) of 2007?
Keep it short and to the point. 4.86e+11. What is the difference between the highest and the second highest Imports (BoP, current US$) in 2008?
Offer a terse response. 5.47e+11. What is the difference between the highest and the lowest Imports (BoP, current US$) in 2005?
Give a very brief answer. 8.56e+12. What is the difference between the highest and the lowest Imports (BoP, current US$) in 2006?
Give a very brief answer. 9.67e+12. What is the difference between the highest and the lowest Imports (BoP, current US$) of 2007?
Your answer should be very brief. 1.10e+13. What is the difference between the highest and the lowest Imports (BoP, current US$) of 2008?
Keep it short and to the point. 1.23e+13. 